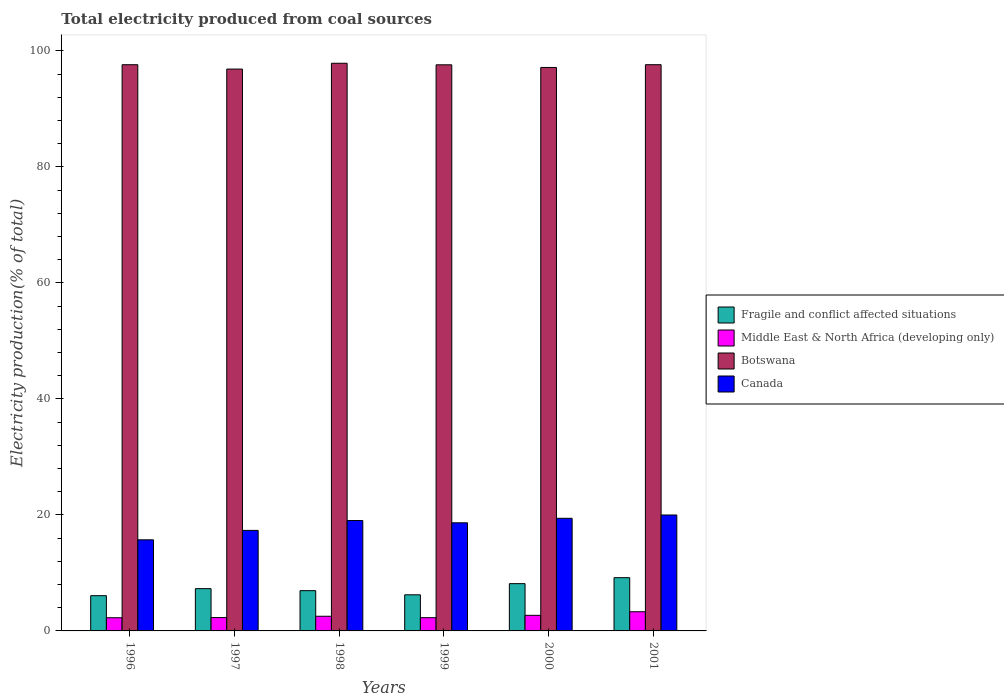How many different coloured bars are there?
Make the answer very short. 4. How many groups of bars are there?
Give a very brief answer. 6. Are the number of bars per tick equal to the number of legend labels?
Offer a terse response. Yes. Are the number of bars on each tick of the X-axis equal?
Your answer should be very brief. Yes. How many bars are there on the 2nd tick from the right?
Your answer should be very brief. 4. What is the label of the 5th group of bars from the left?
Make the answer very short. 2000. In how many cases, is the number of bars for a given year not equal to the number of legend labels?
Make the answer very short. 0. What is the total electricity produced in Botswana in 1999?
Keep it short and to the point. 97.61. Across all years, what is the maximum total electricity produced in Fragile and conflict affected situations?
Offer a terse response. 9.18. Across all years, what is the minimum total electricity produced in Canada?
Make the answer very short. 15.71. In which year was the total electricity produced in Middle East & North Africa (developing only) minimum?
Provide a succinct answer. 1996. What is the total total electricity produced in Fragile and conflict affected situations in the graph?
Provide a short and direct response. 43.86. What is the difference between the total electricity produced in Middle East & North Africa (developing only) in 1996 and that in 1999?
Offer a very short reply. -0.01. What is the difference between the total electricity produced in Middle East & North Africa (developing only) in 1997 and the total electricity produced in Fragile and conflict affected situations in 1999?
Offer a terse response. -3.92. What is the average total electricity produced in Fragile and conflict affected situations per year?
Your response must be concise. 7.31. In the year 1998, what is the difference between the total electricity produced in Canada and total electricity produced in Botswana?
Make the answer very short. -78.84. What is the ratio of the total electricity produced in Canada in 1997 to that in 2000?
Your response must be concise. 0.89. Is the total electricity produced in Canada in 1997 less than that in 1998?
Provide a short and direct response. Yes. Is the difference between the total electricity produced in Canada in 1998 and 2000 greater than the difference between the total electricity produced in Botswana in 1998 and 2000?
Provide a short and direct response. No. What is the difference between the highest and the second highest total electricity produced in Botswana?
Your answer should be very brief. 0.25. What is the difference between the highest and the lowest total electricity produced in Fragile and conflict affected situations?
Your answer should be very brief. 3.1. Is the sum of the total electricity produced in Fragile and conflict affected situations in 2000 and 2001 greater than the maximum total electricity produced in Botswana across all years?
Your answer should be compact. No. Is it the case that in every year, the sum of the total electricity produced in Fragile and conflict affected situations and total electricity produced in Botswana is greater than the sum of total electricity produced in Middle East & North Africa (developing only) and total electricity produced in Canada?
Provide a short and direct response. No. What does the 3rd bar from the left in 1999 represents?
Offer a terse response. Botswana. What does the 2nd bar from the right in 1998 represents?
Offer a terse response. Botswana. Is it the case that in every year, the sum of the total electricity produced in Middle East & North Africa (developing only) and total electricity produced in Botswana is greater than the total electricity produced in Canada?
Your answer should be compact. Yes. How many bars are there?
Make the answer very short. 24. How many years are there in the graph?
Give a very brief answer. 6. What is the difference between two consecutive major ticks on the Y-axis?
Give a very brief answer. 20. Are the values on the major ticks of Y-axis written in scientific E-notation?
Make the answer very short. No. Where does the legend appear in the graph?
Your response must be concise. Center right. How many legend labels are there?
Your answer should be compact. 4. How are the legend labels stacked?
Ensure brevity in your answer.  Vertical. What is the title of the graph?
Ensure brevity in your answer.  Total electricity produced from coal sources. What is the label or title of the X-axis?
Provide a succinct answer. Years. What is the Electricity production(% of total) in Fragile and conflict affected situations in 1996?
Keep it short and to the point. 6.08. What is the Electricity production(% of total) of Middle East & North Africa (developing only) in 1996?
Offer a terse response. 2.27. What is the Electricity production(% of total) of Botswana in 1996?
Make the answer very short. 97.62. What is the Electricity production(% of total) of Canada in 1996?
Give a very brief answer. 15.71. What is the Electricity production(% of total) of Fragile and conflict affected situations in 1997?
Give a very brief answer. 7.29. What is the Electricity production(% of total) of Middle East & North Africa (developing only) in 1997?
Offer a very short reply. 2.3. What is the Electricity production(% of total) of Botswana in 1997?
Provide a short and direct response. 96.87. What is the Electricity production(% of total) in Canada in 1997?
Your answer should be compact. 17.33. What is the Electricity production(% of total) in Fragile and conflict affected situations in 1998?
Your response must be concise. 6.94. What is the Electricity production(% of total) in Middle East & North Africa (developing only) in 1998?
Provide a short and direct response. 2.53. What is the Electricity production(% of total) of Botswana in 1998?
Your answer should be compact. 97.87. What is the Electricity production(% of total) of Canada in 1998?
Give a very brief answer. 19.03. What is the Electricity production(% of total) of Fragile and conflict affected situations in 1999?
Make the answer very short. 6.23. What is the Electricity production(% of total) of Middle East & North Africa (developing only) in 1999?
Your answer should be compact. 2.28. What is the Electricity production(% of total) of Botswana in 1999?
Make the answer very short. 97.61. What is the Electricity production(% of total) of Canada in 1999?
Offer a very short reply. 18.64. What is the Electricity production(% of total) in Fragile and conflict affected situations in 2000?
Keep it short and to the point. 8.15. What is the Electricity production(% of total) in Middle East & North Africa (developing only) in 2000?
Ensure brevity in your answer.  2.69. What is the Electricity production(% of total) in Botswana in 2000?
Provide a short and direct response. 97.15. What is the Electricity production(% of total) of Canada in 2000?
Make the answer very short. 19.42. What is the Electricity production(% of total) in Fragile and conflict affected situations in 2001?
Make the answer very short. 9.18. What is the Electricity production(% of total) of Middle East & North Africa (developing only) in 2001?
Give a very brief answer. 3.31. What is the Electricity production(% of total) in Botswana in 2001?
Offer a terse response. 97.62. What is the Electricity production(% of total) of Canada in 2001?
Provide a succinct answer. 19.99. Across all years, what is the maximum Electricity production(% of total) of Fragile and conflict affected situations?
Provide a short and direct response. 9.18. Across all years, what is the maximum Electricity production(% of total) of Middle East & North Africa (developing only)?
Your response must be concise. 3.31. Across all years, what is the maximum Electricity production(% of total) of Botswana?
Provide a short and direct response. 97.87. Across all years, what is the maximum Electricity production(% of total) in Canada?
Offer a terse response. 19.99. Across all years, what is the minimum Electricity production(% of total) of Fragile and conflict affected situations?
Your answer should be very brief. 6.08. Across all years, what is the minimum Electricity production(% of total) in Middle East & North Africa (developing only)?
Your answer should be compact. 2.27. Across all years, what is the minimum Electricity production(% of total) in Botswana?
Offer a very short reply. 96.87. Across all years, what is the minimum Electricity production(% of total) in Canada?
Provide a succinct answer. 15.71. What is the total Electricity production(% of total) in Fragile and conflict affected situations in the graph?
Ensure brevity in your answer.  43.86. What is the total Electricity production(% of total) in Middle East & North Africa (developing only) in the graph?
Provide a short and direct response. 15.38. What is the total Electricity production(% of total) of Botswana in the graph?
Offer a terse response. 584.74. What is the total Electricity production(% of total) of Canada in the graph?
Give a very brief answer. 110.12. What is the difference between the Electricity production(% of total) in Fragile and conflict affected situations in 1996 and that in 1997?
Ensure brevity in your answer.  -1.21. What is the difference between the Electricity production(% of total) in Middle East & North Africa (developing only) in 1996 and that in 1997?
Keep it short and to the point. -0.03. What is the difference between the Electricity production(% of total) of Botswana in 1996 and that in 1997?
Keep it short and to the point. 0.75. What is the difference between the Electricity production(% of total) in Canada in 1996 and that in 1997?
Give a very brief answer. -1.62. What is the difference between the Electricity production(% of total) in Fragile and conflict affected situations in 1996 and that in 1998?
Your answer should be very brief. -0.87. What is the difference between the Electricity production(% of total) in Middle East & North Africa (developing only) in 1996 and that in 1998?
Offer a very short reply. -0.26. What is the difference between the Electricity production(% of total) of Botswana in 1996 and that in 1998?
Your answer should be compact. -0.25. What is the difference between the Electricity production(% of total) of Canada in 1996 and that in 1998?
Make the answer very short. -3.33. What is the difference between the Electricity production(% of total) in Fragile and conflict affected situations in 1996 and that in 1999?
Provide a succinct answer. -0.15. What is the difference between the Electricity production(% of total) of Middle East & North Africa (developing only) in 1996 and that in 1999?
Provide a succinct answer. -0.01. What is the difference between the Electricity production(% of total) of Botswana in 1996 and that in 1999?
Your answer should be compact. 0.02. What is the difference between the Electricity production(% of total) in Canada in 1996 and that in 1999?
Provide a short and direct response. -2.93. What is the difference between the Electricity production(% of total) of Fragile and conflict affected situations in 1996 and that in 2000?
Provide a succinct answer. -2.08. What is the difference between the Electricity production(% of total) in Middle East & North Africa (developing only) in 1996 and that in 2000?
Give a very brief answer. -0.42. What is the difference between the Electricity production(% of total) of Botswana in 1996 and that in 2000?
Keep it short and to the point. 0.47. What is the difference between the Electricity production(% of total) in Canada in 1996 and that in 2000?
Your response must be concise. -3.71. What is the difference between the Electricity production(% of total) of Fragile and conflict affected situations in 1996 and that in 2001?
Your answer should be very brief. -3.1. What is the difference between the Electricity production(% of total) in Middle East & North Africa (developing only) in 1996 and that in 2001?
Give a very brief answer. -1.04. What is the difference between the Electricity production(% of total) of Botswana in 1996 and that in 2001?
Keep it short and to the point. -0. What is the difference between the Electricity production(% of total) in Canada in 1996 and that in 2001?
Offer a terse response. -4.28. What is the difference between the Electricity production(% of total) of Fragile and conflict affected situations in 1997 and that in 1998?
Offer a terse response. 0.35. What is the difference between the Electricity production(% of total) of Middle East & North Africa (developing only) in 1997 and that in 1998?
Make the answer very short. -0.23. What is the difference between the Electricity production(% of total) in Botswana in 1997 and that in 1998?
Offer a very short reply. -1. What is the difference between the Electricity production(% of total) of Canada in 1997 and that in 1998?
Offer a terse response. -1.7. What is the difference between the Electricity production(% of total) of Fragile and conflict affected situations in 1997 and that in 1999?
Your answer should be very brief. 1.06. What is the difference between the Electricity production(% of total) of Middle East & North Africa (developing only) in 1997 and that in 1999?
Give a very brief answer. 0.02. What is the difference between the Electricity production(% of total) of Botswana in 1997 and that in 1999?
Ensure brevity in your answer.  -0.74. What is the difference between the Electricity production(% of total) of Canada in 1997 and that in 1999?
Give a very brief answer. -1.31. What is the difference between the Electricity production(% of total) in Fragile and conflict affected situations in 1997 and that in 2000?
Your answer should be compact. -0.86. What is the difference between the Electricity production(% of total) of Middle East & North Africa (developing only) in 1997 and that in 2000?
Your response must be concise. -0.39. What is the difference between the Electricity production(% of total) of Botswana in 1997 and that in 2000?
Make the answer very short. -0.28. What is the difference between the Electricity production(% of total) in Canada in 1997 and that in 2000?
Make the answer very short. -2.09. What is the difference between the Electricity production(% of total) of Fragile and conflict affected situations in 1997 and that in 2001?
Provide a short and direct response. -1.89. What is the difference between the Electricity production(% of total) of Middle East & North Africa (developing only) in 1997 and that in 2001?
Make the answer very short. -1.01. What is the difference between the Electricity production(% of total) in Botswana in 1997 and that in 2001?
Keep it short and to the point. -0.75. What is the difference between the Electricity production(% of total) in Canada in 1997 and that in 2001?
Offer a terse response. -2.66. What is the difference between the Electricity production(% of total) of Fragile and conflict affected situations in 1998 and that in 1999?
Give a very brief answer. 0.72. What is the difference between the Electricity production(% of total) of Middle East & North Africa (developing only) in 1998 and that in 1999?
Provide a succinct answer. 0.24. What is the difference between the Electricity production(% of total) in Botswana in 1998 and that in 1999?
Make the answer very short. 0.27. What is the difference between the Electricity production(% of total) of Canada in 1998 and that in 1999?
Keep it short and to the point. 0.39. What is the difference between the Electricity production(% of total) in Fragile and conflict affected situations in 1998 and that in 2000?
Ensure brevity in your answer.  -1.21. What is the difference between the Electricity production(% of total) in Middle East & North Africa (developing only) in 1998 and that in 2000?
Your answer should be compact. -0.16. What is the difference between the Electricity production(% of total) of Botswana in 1998 and that in 2000?
Offer a very short reply. 0.72. What is the difference between the Electricity production(% of total) of Canada in 1998 and that in 2000?
Keep it short and to the point. -0.38. What is the difference between the Electricity production(% of total) of Fragile and conflict affected situations in 1998 and that in 2001?
Ensure brevity in your answer.  -2.24. What is the difference between the Electricity production(% of total) of Middle East & North Africa (developing only) in 1998 and that in 2001?
Keep it short and to the point. -0.78. What is the difference between the Electricity production(% of total) of Botswana in 1998 and that in 2001?
Offer a terse response. 0.25. What is the difference between the Electricity production(% of total) of Canada in 1998 and that in 2001?
Provide a succinct answer. -0.95. What is the difference between the Electricity production(% of total) of Fragile and conflict affected situations in 1999 and that in 2000?
Offer a very short reply. -1.93. What is the difference between the Electricity production(% of total) in Middle East & North Africa (developing only) in 1999 and that in 2000?
Offer a very short reply. -0.41. What is the difference between the Electricity production(% of total) in Botswana in 1999 and that in 2000?
Give a very brief answer. 0.46. What is the difference between the Electricity production(% of total) in Canada in 1999 and that in 2000?
Give a very brief answer. -0.78. What is the difference between the Electricity production(% of total) in Fragile and conflict affected situations in 1999 and that in 2001?
Keep it short and to the point. -2.95. What is the difference between the Electricity production(% of total) in Middle East & North Africa (developing only) in 1999 and that in 2001?
Provide a short and direct response. -1.02. What is the difference between the Electricity production(% of total) of Botswana in 1999 and that in 2001?
Your answer should be very brief. -0.02. What is the difference between the Electricity production(% of total) in Canada in 1999 and that in 2001?
Offer a very short reply. -1.35. What is the difference between the Electricity production(% of total) of Fragile and conflict affected situations in 2000 and that in 2001?
Provide a short and direct response. -1.03. What is the difference between the Electricity production(% of total) in Middle East & North Africa (developing only) in 2000 and that in 2001?
Keep it short and to the point. -0.62. What is the difference between the Electricity production(% of total) in Botswana in 2000 and that in 2001?
Give a very brief answer. -0.47. What is the difference between the Electricity production(% of total) of Canada in 2000 and that in 2001?
Keep it short and to the point. -0.57. What is the difference between the Electricity production(% of total) of Fragile and conflict affected situations in 1996 and the Electricity production(% of total) of Middle East & North Africa (developing only) in 1997?
Ensure brevity in your answer.  3.77. What is the difference between the Electricity production(% of total) of Fragile and conflict affected situations in 1996 and the Electricity production(% of total) of Botswana in 1997?
Offer a very short reply. -90.8. What is the difference between the Electricity production(% of total) of Fragile and conflict affected situations in 1996 and the Electricity production(% of total) of Canada in 1997?
Offer a terse response. -11.25. What is the difference between the Electricity production(% of total) of Middle East & North Africa (developing only) in 1996 and the Electricity production(% of total) of Botswana in 1997?
Ensure brevity in your answer.  -94.6. What is the difference between the Electricity production(% of total) in Middle East & North Africa (developing only) in 1996 and the Electricity production(% of total) in Canada in 1997?
Offer a very short reply. -15.06. What is the difference between the Electricity production(% of total) in Botswana in 1996 and the Electricity production(% of total) in Canada in 1997?
Keep it short and to the point. 80.29. What is the difference between the Electricity production(% of total) of Fragile and conflict affected situations in 1996 and the Electricity production(% of total) of Middle East & North Africa (developing only) in 1998?
Offer a terse response. 3.55. What is the difference between the Electricity production(% of total) of Fragile and conflict affected situations in 1996 and the Electricity production(% of total) of Botswana in 1998?
Keep it short and to the point. -91.8. What is the difference between the Electricity production(% of total) of Fragile and conflict affected situations in 1996 and the Electricity production(% of total) of Canada in 1998?
Your response must be concise. -12.96. What is the difference between the Electricity production(% of total) of Middle East & North Africa (developing only) in 1996 and the Electricity production(% of total) of Botswana in 1998?
Offer a very short reply. -95.6. What is the difference between the Electricity production(% of total) of Middle East & North Africa (developing only) in 1996 and the Electricity production(% of total) of Canada in 1998?
Offer a very short reply. -16.76. What is the difference between the Electricity production(% of total) in Botswana in 1996 and the Electricity production(% of total) in Canada in 1998?
Your response must be concise. 78.59. What is the difference between the Electricity production(% of total) of Fragile and conflict affected situations in 1996 and the Electricity production(% of total) of Middle East & North Africa (developing only) in 1999?
Offer a terse response. 3.79. What is the difference between the Electricity production(% of total) of Fragile and conflict affected situations in 1996 and the Electricity production(% of total) of Botswana in 1999?
Your answer should be compact. -91.53. What is the difference between the Electricity production(% of total) in Fragile and conflict affected situations in 1996 and the Electricity production(% of total) in Canada in 1999?
Ensure brevity in your answer.  -12.56. What is the difference between the Electricity production(% of total) of Middle East & North Africa (developing only) in 1996 and the Electricity production(% of total) of Botswana in 1999?
Give a very brief answer. -95.33. What is the difference between the Electricity production(% of total) in Middle East & North Africa (developing only) in 1996 and the Electricity production(% of total) in Canada in 1999?
Offer a very short reply. -16.37. What is the difference between the Electricity production(% of total) of Botswana in 1996 and the Electricity production(% of total) of Canada in 1999?
Provide a succinct answer. 78.98. What is the difference between the Electricity production(% of total) in Fragile and conflict affected situations in 1996 and the Electricity production(% of total) in Middle East & North Africa (developing only) in 2000?
Ensure brevity in your answer.  3.39. What is the difference between the Electricity production(% of total) of Fragile and conflict affected situations in 1996 and the Electricity production(% of total) of Botswana in 2000?
Your answer should be very brief. -91.07. What is the difference between the Electricity production(% of total) in Fragile and conflict affected situations in 1996 and the Electricity production(% of total) in Canada in 2000?
Give a very brief answer. -13.34. What is the difference between the Electricity production(% of total) of Middle East & North Africa (developing only) in 1996 and the Electricity production(% of total) of Botswana in 2000?
Your answer should be very brief. -94.88. What is the difference between the Electricity production(% of total) of Middle East & North Africa (developing only) in 1996 and the Electricity production(% of total) of Canada in 2000?
Give a very brief answer. -17.14. What is the difference between the Electricity production(% of total) in Botswana in 1996 and the Electricity production(% of total) in Canada in 2000?
Give a very brief answer. 78.21. What is the difference between the Electricity production(% of total) of Fragile and conflict affected situations in 1996 and the Electricity production(% of total) of Middle East & North Africa (developing only) in 2001?
Your answer should be compact. 2.77. What is the difference between the Electricity production(% of total) of Fragile and conflict affected situations in 1996 and the Electricity production(% of total) of Botswana in 2001?
Provide a succinct answer. -91.55. What is the difference between the Electricity production(% of total) of Fragile and conflict affected situations in 1996 and the Electricity production(% of total) of Canada in 2001?
Keep it short and to the point. -13.91. What is the difference between the Electricity production(% of total) in Middle East & North Africa (developing only) in 1996 and the Electricity production(% of total) in Botswana in 2001?
Offer a terse response. -95.35. What is the difference between the Electricity production(% of total) of Middle East & North Africa (developing only) in 1996 and the Electricity production(% of total) of Canada in 2001?
Ensure brevity in your answer.  -17.72. What is the difference between the Electricity production(% of total) of Botswana in 1996 and the Electricity production(% of total) of Canada in 2001?
Your answer should be very brief. 77.63. What is the difference between the Electricity production(% of total) of Fragile and conflict affected situations in 1997 and the Electricity production(% of total) of Middle East & North Africa (developing only) in 1998?
Provide a succinct answer. 4.76. What is the difference between the Electricity production(% of total) of Fragile and conflict affected situations in 1997 and the Electricity production(% of total) of Botswana in 1998?
Keep it short and to the point. -90.58. What is the difference between the Electricity production(% of total) of Fragile and conflict affected situations in 1997 and the Electricity production(% of total) of Canada in 1998?
Offer a very short reply. -11.75. What is the difference between the Electricity production(% of total) of Middle East & North Africa (developing only) in 1997 and the Electricity production(% of total) of Botswana in 1998?
Provide a short and direct response. -95.57. What is the difference between the Electricity production(% of total) in Middle East & North Africa (developing only) in 1997 and the Electricity production(% of total) in Canada in 1998?
Provide a short and direct response. -16.73. What is the difference between the Electricity production(% of total) of Botswana in 1997 and the Electricity production(% of total) of Canada in 1998?
Offer a terse response. 77.84. What is the difference between the Electricity production(% of total) of Fragile and conflict affected situations in 1997 and the Electricity production(% of total) of Middle East & North Africa (developing only) in 1999?
Make the answer very short. 5. What is the difference between the Electricity production(% of total) in Fragile and conflict affected situations in 1997 and the Electricity production(% of total) in Botswana in 1999?
Keep it short and to the point. -90.32. What is the difference between the Electricity production(% of total) in Fragile and conflict affected situations in 1997 and the Electricity production(% of total) in Canada in 1999?
Offer a very short reply. -11.35. What is the difference between the Electricity production(% of total) in Middle East & North Africa (developing only) in 1997 and the Electricity production(% of total) in Botswana in 1999?
Make the answer very short. -95.3. What is the difference between the Electricity production(% of total) of Middle East & North Africa (developing only) in 1997 and the Electricity production(% of total) of Canada in 1999?
Provide a short and direct response. -16.34. What is the difference between the Electricity production(% of total) of Botswana in 1997 and the Electricity production(% of total) of Canada in 1999?
Offer a very short reply. 78.23. What is the difference between the Electricity production(% of total) of Fragile and conflict affected situations in 1997 and the Electricity production(% of total) of Middle East & North Africa (developing only) in 2000?
Ensure brevity in your answer.  4.6. What is the difference between the Electricity production(% of total) in Fragile and conflict affected situations in 1997 and the Electricity production(% of total) in Botswana in 2000?
Your answer should be very brief. -89.86. What is the difference between the Electricity production(% of total) in Fragile and conflict affected situations in 1997 and the Electricity production(% of total) in Canada in 2000?
Provide a succinct answer. -12.13. What is the difference between the Electricity production(% of total) in Middle East & North Africa (developing only) in 1997 and the Electricity production(% of total) in Botswana in 2000?
Offer a terse response. -94.85. What is the difference between the Electricity production(% of total) of Middle East & North Africa (developing only) in 1997 and the Electricity production(% of total) of Canada in 2000?
Offer a terse response. -17.12. What is the difference between the Electricity production(% of total) of Botswana in 1997 and the Electricity production(% of total) of Canada in 2000?
Ensure brevity in your answer.  77.45. What is the difference between the Electricity production(% of total) of Fragile and conflict affected situations in 1997 and the Electricity production(% of total) of Middle East & North Africa (developing only) in 2001?
Offer a terse response. 3.98. What is the difference between the Electricity production(% of total) in Fragile and conflict affected situations in 1997 and the Electricity production(% of total) in Botswana in 2001?
Your response must be concise. -90.34. What is the difference between the Electricity production(% of total) of Fragile and conflict affected situations in 1997 and the Electricity production(% of total) of Canada in 2001?
Provide a succinct answer. -12.7. What is the difference between the Electricity production(% of total) in Middle East & North Africa (developing only) in 1997 and the Electricity production(% of total) in Botswana in 2001?
Your answer should be compact. -95.32. What is the difference between the Electricity production(% of total) of Middle East & North Africa (developing only) in 1997 and the Electricity production(% of total) of Canada in 2001?
Give a very brief answer. -17.69. What is the difference between the Electricity production(% of total) in Botswana in 1997 and the Electricity production(% of total) in Canada in 2001?
Give a very brief answer. 76.88. What is the difference between the Electricity production(% of total) in Fragile and conflict affected situations in 1998 and the Electricity production(% of total) in Middle East & North Africa (developing only) in 1999?
Provide a short and direct response. 4.66. What is the difference between the Electricity production(% of total) of Fragile and conflict affected situations in 1998 and the Electricity production(% of total) of Botswana in 1999?
Ensure brevity in your answer.  -90.66. What is the difference between the Electricity production(% of total) of Fragile and conflict affected situations in 1998 and the Electricity production(% of total) of Canada in 1999?
Your answer should be compact. -11.7. What is the difference between the Electricity production(% of total) of Middle East & North Africa (developing only) in 1998 and the Electricity production(% of total) of Botswana in 1999?
Your answer should be compact. -95.08. What is the difference between the Electricity production(% of total) in Middle East & North Africa (developing only) in 1998 and the Electricity production(% of total) in Canada in 1999?
Make the answer very short. -16.11. What is the difference between the Electricity production(% of total) of Botswana in 1998 and the Electricity production(% of total) of Canada in 1999?
Keep it short and to the point. 79.23. What is the difference between the Electricity production(% of total) of Fragile and conflict affected situations in 1998 and the Electricity production(% of total) of Middle East & North Africa (developing only) in 2000?
Your response must be concise. 4.25. What is the difference between the Electricity production(% of total) in Fragile and conflict affected situations in 1998 and the Electricity production(% of total) in Botswana in 2000?
Your response must be concise. -90.21. What is the difference between the Electricity production(% of total) in Fragile and conflict affected situations in 1998 and the Electricity production(% of total) in Canada in 2000?
Your response must be concise. -12.48. What is the difference between the Electricity production(% of total) in Middle East & North Africa (developing only) in 1998 and the Electricity production(% of total) in Botswana in 2000?
Ensure brevity in your answer.  -94.62. What is the difference between the Electricity production(% of total) in Middle East & North Africa (developing only) in 1998 and the Electricity production(% of total) in Canada in 2000?
Offer a very short reply. -16.89. What is the difference between the Electricity production(% of total) in Botswana in 1998 and the Electricity production(% of total) in Canada in 2000?
Your answer should be very brief. 78.46. What is the difference between the Electricity production(% of total) of Fragile and conflict affected situations in 1998 and the Electricity production(% of total) of Middle East & North Africa (developing only) in 2001?
Your answer should be very brief. 3.63. What is the difference between the Electricity production(% of total) in Fragile and conflict affected situations in 1998 and the Electricity production(% of total) in Botswana in 2001?
Provide a short and direct response. -90.68. What is the difference between the Electricity production(% of total) of Fragile and conflict affected situations in 1998 and the Electricity production(% of total) of Canada in 2001?
Your response must be concise. -13.05. What is the difference between the Electricity production(% of total) of Middle East & North Africa (developing only) in 1998 and the Electricity production(% of total) of Botswana in 2001?
Offer a terse response. -95.09. What is the difference between the Electricity production(% of total) of Middle East & North Africa (developing only) in 1998 and the Electricity production(% of total) of Canada in 2001?
Ensure brevity in your answer.  -17.46. What is the difference between the Electricity production(% of total) in Botswana in 1998 and the Electricity production(% of total) in Canada in 2001?
Keep it short and to the point. 77.88. What is the difference between the Electricity production(% of total) of Fragile and conflict affected situations in 1999 and the Electricity production(% of total) of Middle East & North Africa (developing only) in 2000?
Your answer should be compact. 3.54. What is the difference between the Electricity production(% of total) of Fragile and conflict affected situations in 1999 and the Electricity production(% of total) of Botswana in 2000?
Offer a terse response. -90.92. What is the difference between the Electricity production(% of total) of Fragile and conflict affected situations in 1999 and the Electricity production(% of total) of Canada in 2000?
Ensure brevity in your answer.  -13.19. What is the difference between the Electricity production(% of total) in Middle East & North Africa (developing only) in 1999 and the Electricity production(% of total) in Botswana in 2000?
Your answer should be compact. -94.86. What is the difference between the Electricity production(% of total) of Middle East & North Africa (developing only) in 1999 and the Electricity production(% of total) of Canada in 2000?
Keep it short and to the point. -17.13. What is the difference between the Electricity production(% of total) of Botswana in 1999 and the Electricity production(% of total) of Canada in 2000?
Ensure brevity in your answer.  78.19. What is the difference between the Electricity production(% of total) of Fragile and conflict affected situations in 1999 and the Electricity production(% of total) of Middle East & North Africa (developing only) in 2001?
Keep it short and to the point. 2.92. What is the difference between the Electricity production(% of total) of Fragile and conflict affected situations in 1999 and the Electricity production(% of total) of Botswana in 2001?
Provide a short and direct response. -91.4. What is the difference between the Electricity production(% of total) in Fragile and conflict affected situations in 1999 and the Electricity production(% of total) in Canada in 2001?
Your response must be concise. -13.76. What is the difference between the Electricity production(% of total) in Middle East & North Africa (developing only) in 1999 and the Electricity production(% of total) in Botswana in 2001?
Offer a very short reply. -95.34. What is the difference between the Electricity production(% of total) of Middle East & North Africa (developing only) in 1999 and the Electricity production(% of total) of Canada in 2001?
Offer a very short reply. -17.7. What is the difference between the Electricity production(% of total) in Botswana in 1999 and the Electricity production(% of total) in Canada in 2001?
Offer a very short reply. 77.62. What is the difference between the Electricity production(% of total) in Fragile and conflict affected situations in 2000 and the Electricity production(% of total) in Middle East & North Africa (developing only) in 2001?
Keep it short and to the point. 4.84. What is the difference between the Electricity production(% of total) of Fragile and conflict affected situations in 2000 and the Electricity production(% of total) of Botswana in 2001?
Your answer should be very brief. -89.47. What is the difference between the Electricity production(% of total) in Fragile and conflict affected situations in 2000 and the Electricity production(% of total) in Canada in 2001?
Provide a short and direct response. -11.84. What is the difference between the Electricity production(% of total) of Middle East & North Africa (developing only) in 2000 and the Electricity production(% of total) of Botswana in 2001?
Provide a short and direct response. -94.93. What is the difference between the Electricity production(% of total) of Middle East & North Africa (developing only) in 2000 and the Electricity production(% of total) of Canada in 2001?
Provide a succinct answer. -17.3. What is the difference between the Electricity production(% of total) of Botswana in 2000 and the Electricity production(% of total) of Canada in 2001?
Make the answer very short. 77.16. What is the average Electricity production(% of total) in Fragile and conflict affected situations per year?
Make the answer very short. 7.31. What is the average Electricity production(% of total) in Middle East & North Africa (developing only) per year?
Offer a very short reply. 2.56. What is the average Electricity production(% of total) of Botswana per year?
Offer a terse response. 97.46. What is the average Electricity production(% of total) of Canada per year?
Give a very brief answer. 18.35. In the year 1996, what is the difference between the Electricity production(% of total) in Fragile and conflict affected situations and Electricity production(% of total) in Middle East & North Africa (developing only)?
Make the answer very short. 3.8. In the year 1996, what is the difference between the Electricity production(% of total) in Fragile and conflict affected situations and Electricity production(% of total) in Botswana?
Give a very brief answer. -91.55. In the year 1996, what is the difference between the Electricity production(% of total) of Fragile and conflict affected situations and Electricity production(% of total) of Canada?
Offer a very short reply. -9.63. In the year 1996, what is the difference between the Electricity production(% of total) of Middle East & North Africa (developing only) and Electricity production(% of total) of Botswana?
Offer a very short reply. -95.35. In the year 1996, what is the difference between the Electricity production(% of total) of Middle East & North Africa (developing only) and Electricity production(% of total) of Canada?
Give a very brief answer. -13.43. In the year 1996, what is the difference between the Electricity production(% of total) of Botswana and Electricity production(% of total) of Canada?
Give a very brief answer. 81.91. In the year 1997, what is the difference between the Electricity production(% of total) of Fragile and conflict affected situations and Electricity production(% of total) of Middle East & North Africa (developing only)?
Provide a succinct answer. 4.99. In the year 1997, what is the difference between the Electricity production(% of total) in Fragile and conflict affected situations and Electricity production(% of total) in Botswana?
Offer a terse response. -89.58. In the year 1997, what is the difference between the Electricity production(% of total) in Fragile and conflict affected situations and Electricity production(% of total) in Canada?
Offer a very short reply. -10.04. In the year 1997, what is the difference between the Electricity production(% of total) of Middle East & North Africa (developing only) and Electricity production(% of total) of Botswana?
Provide a short and direct response. -94.57. In the year 1997, what is the difference between the Electricity production(% of total) in Middle East & North Africa (developing only) and Electricity production(% of total) in Canada?
Make the answer very short. -15.03. In the year 1997, what is the difference between the Electricity production(% of total) of Botswana and Electricity production(% of total) of Canada?
Offer a very short reply. 79.54. In the year 1998, what is the difference between the Electricity production(% of total) in Fragile and conflict affected situations and Electricity production(% of total) in Middle East & North Africa (developing only)?
Your response must be concise. 4.41. In the year 1998, what is the difference between the Electricity production(% of total) in Fragile and conflict affected situations and Electricity production(% of total) in Botswana?
Your answer should be compact. -90.93. In the year 1998, what is the difference between the Electricity production(% of total) in Fragile and conflict affected situations and Electricity production(% of total) in Canada?
Keep it short and to the point. -12.09. In the year 1998, what is the difference between the Electricity production(% of total) in Middle East & North Africa (developing only) and Electricity production(% of total) in Botswana?
Make the answer very short. -95.34. In the year 1998, what is the difference between the Electricity production(% of total) of Middle East & North Africa (developing only) and Electricity production(% of total) of Canada?
Ensure brevity in your answer.  -16.51. In the year 1998, what is the difference between the Electricity production(% of total) in Botswana and Electricity production(% of total) in Canada?
Ensure brevity in your answer.  78.84. In the year 1999, what is the difference between the Electricity production(% of total) of Fragile and conflict affected situations and Electricity production(% of total) of Middle East & North Africa (developing only)?
Ensure brevity in your answer.  3.94. In the year 1999, what is the difference between the Electricity production(% of total) of Fragile and conflict affected situations and Electricity production(% of total) of Botswana?
Make the answer very short. -91.38. In the year 1999, what is the difference between the Electricity production(% of total) in Fragile and conflict affected situations and Electricity production(% of total) in Canada?
Provide a short and direct response. -12.41. In the year 1999, what is the difference between the Electricity production(% of total) of Middle East & North Africa (developing only) and Electricity production(% of total) of Botswana?
Provide a succinct answer. -95.32. In the year 1999, what is the difference between the Electricity production(% of total) of Middle East & North Africa (developing only) and Electricity production(% of total) of Canada?
Provide a short and direct response. -16.36. In the year 1999, what is the difference between the Electricity production(% of total) in Botswana and Electricity production(% of total) in Canada?
Provide a short and direct response. 78.97. In the year 2000, what is the difference between the Electricity production(% of total) in Fragile and conflict affected situations and Electricity production(% of total) in Middle East & North Africa (developing only)?
Your response must be concise. 5.46. In the year 2000, what is the difference between the Electricity production(% of total) in Fragile and conflict affected situations and Electricity production(% of total) in Botswana?
Offer a very short reply. -89. In the year 2000, what is the difference between the Electricity production(% of total) of Fragile and conflict affected situations and Electricity production(% of total) of Canada?
Provide a short and direct response. -11.27. In the year 2000, what is the difference between the Electricity production(% of total) of Middle East & North Africa (developing only) and Electricity production(% of total) of Botswana?
Provide a short and direct response. -94.46. In the year 2000, what is the difference between the Electricity production(% of total) of Middle East & North Africa (developing only) and Electricity production(% of total) of Canada?
Give a very brief answer. -16.73. In the year 2000, what is the difference between the Electricity production(% of total) of Botswana and Electricity production(% of total) of Canada?
Ensure brevity in your answer.  77.73. In the year 2001, what is the difference between the Electricity production(% of total) in Fragile and conflict affected situations and Electricity production(% of total) in Middle East & North Africa (developing only)?
Give a very brief answer. 5.87. In the year 2001, what is the difference between the Electricity production(% of total) of Fragile and conflict affected situations and Electricity production(% of total) of Botswana?
Your answer should be very brief. -88.44. In the year 2001, what is the difference between the Electricity production(% of total) in Fragile and conflict affected situations and Electricity production(% of total) in Canada?
Offer a very short reply. -10.81. In the year 2001, what is the difference between the Electricity production(% of total) in Middle East & North Africa (developing only) and Electricity production(% of total) in Botswana?
Give a very brief answer. -94.32. In the year 2001, what is the difference between the Electricity production(% of total) in Middle East & North Africa (developing only) and Electricity production(% of total) in Canada?
Make the answer very short. -16.68. In the year 2001, what is the difference between the Electricity production(% of total) in Botswana and Electricity production(% of total) in Canada?
Keep it short and to the point. 77.63. What is the ratio of the Electricity production(% of total) of Fragile and conflict affected situations in 1996 to that in 1997?
Provide a short and direct response. 0.83. What is the ratio of the Electricity production(% of total) in Middle East & North Africa (developing only) in 1996 to that in 1997?
Your response must be concise. 0.99. What is the ratio of the Electricity production(% of total) of Canada in 1996 to that in 1997?
Provide a succinct answer. 0.91. What is the ratio of the Electricity production(% of total) in Fragile and conflict affected situations in 1996 to that in 1998?
Your answer should be compact. 0.88. What is the ratio of the Electricity production(% of total) of Middle East & North Africa (developing only) in 1996 to that in 1998?
Your answer should be very brief. 0.9. What is the ratio of the Electricity production(% of total) in Botswana in 1996 to that in 1998?
Keep it short and to the point. 1. What is the ratio of the Electricity production(% of total) in Canada in 1996 to that in 1998?
Your answer should be very brief. 0.83. What is the ratio of the Electricity production(% of total) in Fragile and conflict affected situations in 1996 to that in 1999?
Offer a very short reply. 0.98. What is the ratio of the Electricity production(% of total) of Middle East & North Africa (developing only) in 1996 to that in 1999?
Your response must be concise. 0.99. What is the ratio of the Electricity production(% of total) of Canada in 1996 to that in 1999?
Provide a short and direct response. 0.84. What is the ratio of the Electricity production(% of total) of Fragile and conflict affected situations in 1996 to that in 2000?
Keep it short and to the point. 0.75. What is the ratio of the Electricity production(% of total) in Middle East & North Africa (developing only) in 1996 to that in 2000?
Your answer should be compact. 0.84. What is the ratio of the Electricity production(% of total) of Canada in 1996 to that in 2000?
Provide a succinct answer. 0.81. What is the ratio of the Electricity production(% of total) of Fragile and conflict affected situations in 1996 to that in 2001?
Your answer should be very brief. 0.66. What is the ratio of the Electricity production(% of total) in Middle East & North Africa (developing only) in 1996 to that in 2001?
Ensure brevity in your answer.  0.69. What is the ratio of the Electricity production(% of total) in Botswana in 1996 to that in 2001?
Give a very brief answer. 1. What is the ratio of the Electricity production(% of total) of Canada in 1996 to that in 2001?
Your answer should be very brief. 0.79. What is the ratio of the Electricity production(% of total) of Fragile and conflict affected situations in 1997 to that in 1998?
Your response must be concise. 1.05. What is the ratio of the Electricity production(% of total) of Middle East & North Africa (developing only) in 1997 to that in 1998?
Ensure brevity in your answer.  0.91. What is the ratio of the Electricity production(% of total) in Botswana in 1997 to that in 1998?
Provide a short and direct response. 0.99. What is the ratio of the Electricity production(% of total) in Canada in 1997 to that in 1998?
Offer a very short reply. 0.91. What is the ratio of the Electricity production(% of total) in Fragile and conflict affected situations in 1997 to that in 1999?
Offer a terse response. 1.17. What is the ratio of the Electricity production(% of total) in Middle East & North Africa (developing only) in 1997 to that in 1999?
Make the answer very short. 1.01. What is the ratio of the Electricity production(% of total) of Botswana in 1997 to that in 1999?
Your answer should be compact. 0.99. What is the ratio of the Electricity production(% of total) in Canada in 1997 to that in 1999?
Your answer should be very brief. 0.93. What is the ratio of the Electricity production(% of total) in Fragile and conflict affected situations in 1997 to that in 2000?
Provide a short and direct response. 0.89. What is the ratio of the Electricity production(% of total) in Middle East & North Africa (developing only) in 1997 to that in 2000?
Your answer should be compact. 0.86. What is the ratio of the Electricity production(% of total) in Canada in 1997 to that in 2000?
Provide a short and direct response. 0.89. What is the ratio of the Electricity production(% of total) of Fragile and conflict affected situations in 1997 to that in 2001?
Provide a succinct answer. 0.79. What is the ratio of the Electricity production(% of total) in Middle East & North Africa (developing only) in 1997 to that in 2001?
Your answer should be compact. 0.7. What is the ratio of the Electricity production(% of total) of Canada in 1997 to that in 2001?
Offer a terse response. 0.87. What is the ratio of the Electricity production(% of total) of Fragile and conflict affected situations in 1998 to that in 1999?
Offer a very short reply. 1.11. What is the ratio of the Electricity production(% of total) of Middle East & North Africa (developing only) in 1998 to that in 1999?
Your response must be concise. 1.11. What is the ratio of the Electricity production(% of total) of Canada in 1998 to that in 1999?
Provide a succinct answer. 1.02. What is the ratio of the Electricity production(% of total) in Fragile and conflict affected situations in 1998 to that in 2000?
Provide a succinct answer. 0.85. What is the ratio of the Electricity production(% of total) of Middle East & North Africa (developing only) in 1998 to that in 2000?
Offer a very short reply. 0.94. What is the ratio of the Electricity production(% of total) of Botswana in 1998 to that in 2000?
Provide a short and direct response. 1.01. What is the ratio of the Electricity production(% of total) of Canada in 1998 to that in 2000?
Offer a very short reply. 0.98. What is the ratio of the Electricity production(% of total) in Fragile and conflict affected situations in 1998 to that in 2001?
Your answer should be very brief. 0.76. What is the ratio of the Electricity production(% of total) of Middle East & North Africa (developing only) in 1998 to that in 2001?
Your answer should be very brief. 0.76. What is the ratio of the Electricity production(% of total) in Botswana in 1998 to that in 2001?
Provide a short and direct response. 1. What is the ratio of the Electricity production(% of total) of Canada in 1998 to that in 2001?
Give a very brief answer. 0.95. What is the ratio of the Electricity production(% of total) of Fragile and conflict affected situations in 1999 to that in 2000?
Your response must be concise. 0.76. What is the ratio of the Electricity production(% of total) of Middle East & North Africa (developing only) in 1999 to that in 2000?
Offer a terse response. 0.85. What is the ratio of the Electricity production(% of total) in Botswana in 1999 to that in 2000?
Provide a short and direct response. 1. What is the ratio of the Electricity production(% of total) in Fragile and conflict affected situations in 1999 to that in 2001?
Provide a succinct answer. 0.68. What is the ratio of the Electricity production(% of total) of Middle East & North Africa (developing only) in 1999 to that in 2001?
Provide a succinct answer. 0.69. What is the ratio of the Electricity production(% of total) in Botswana in 1999 to that in 2001?
Provide a short and direct response. 1. What is the ratio of the Electricity production(% of total) of Canada in 1999 to that in 2001?
Keep it short and to the point. 0.93. What is the ratio of the Electricity production(% of total) of Fragile and conflict affected situations in 2000 to that in 2001?
Your response must be concise. 0.89. What is the ratio of the Electricity production(% of total) in Middle East & North Africa (developing only) in 2000 to that in 2001?
Your response must be concise. 0.81. What is the ratio of the Electricity production(% of total) of Botswana in 2000 to that in 2001?
Your answer should be very brief. 1. What is the ratio of the Electricity production(% of total) in Canada in 2000 to that in 2001?
Offer a very short reply. 0.97. What is the difference between the highest and the second highest Electricity production(% of total) of Fragile and conflict affected situations?
Provide a succinct answer. 1.03. What is the difference between the highest and the second highest Electricity production(% of total) of Middle East & North Africa (developing only)?
Offer a terse response. 0.62. What is the difference between the highest and the second highest Electricity production(% of total) in Botswana?
Your answer should be very brief. 0.25. What is the difference between the highest and the second highest Electricity production(% of total) of Canada?
Ensure brevity in your answer.  0.57. What is the difference between the highest and the lowest Electricity production(% of total) in Fragile and conflict affected situations?
Offer a very short reply. 3.1. What is the difference between the highest and the lowest Electricity production(% of total) in Middle East & North Africa (developing only)?
Offer a very short reply. 1.04. What is the difference between the highest and the lowest Electricity production(% of total) of Canada?
Provide a succinct answer. 4.28. 